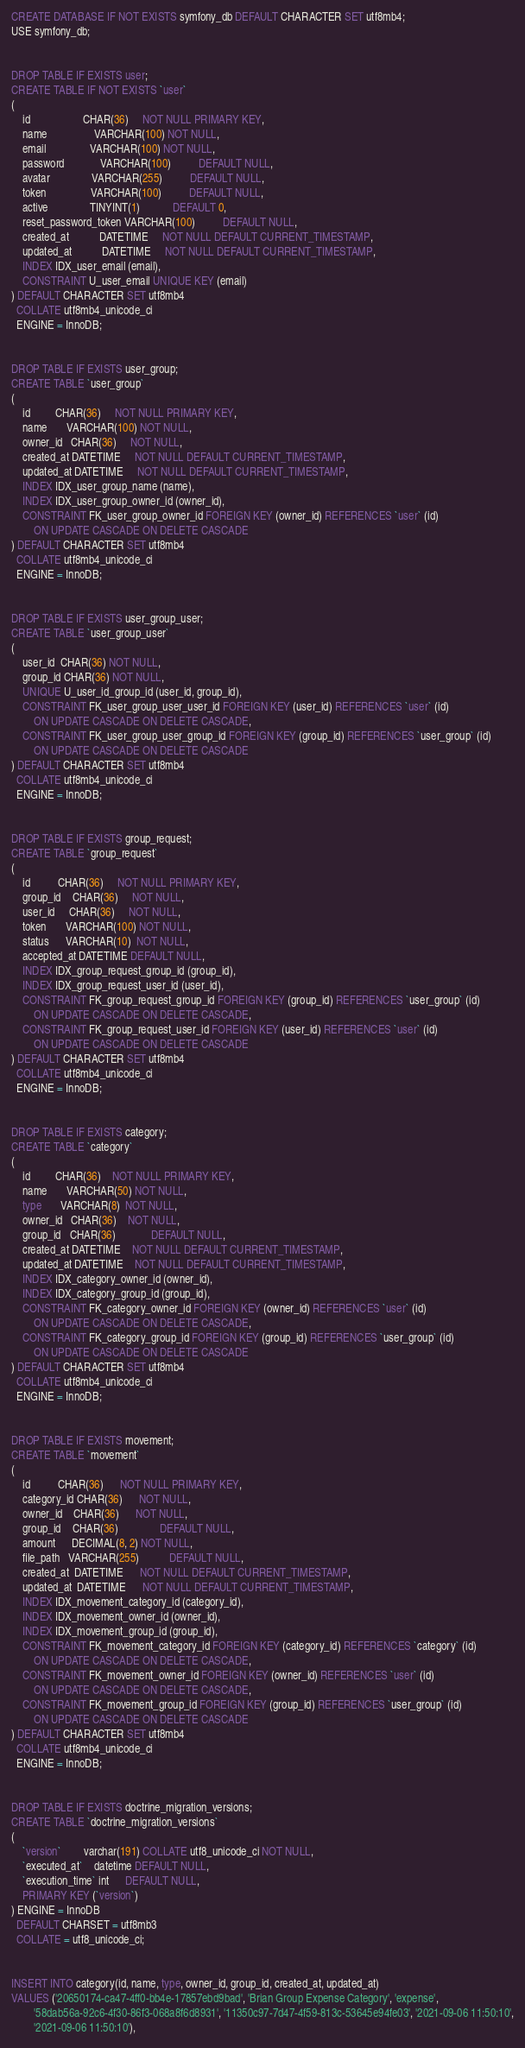Convert code to text. <code><loc_0><loc_0><loc_500><loc_500><_SQL_>CREATE DATABASE IF NOT EXISTS symfony_db DEFAULT CHARACTER SET utf8mb4;
USE symfony_db;


DROP TABLE IF EXISTS user;
CREATE TABLE IF NOT EXISTS `user`
(
    id                   CHAR(36)     NOT NULL PRIMARY KEY,
    name                 VARCHAR(100) NOT NULL,
    email                VARCHAR(100) NOT NULL,
    password             VARCHAR(100)          DEFAULT NULL,
    avatar               VARCHAR(255)          DEFAULT NULL,
    token                VARCHAR(100)          DEFAULT NULL,
    active               TINYINT(1)            DEFAULT 0,
    reset_password_token VARCHAR(100)          DEFAULT NULL,
    created_at           DATETIME     NOT NULL DEFAULT CURRENT_TIMESTAMP,
    updated_at           DATETIME     NOT NULL DEFAULT CURRENT_TIMESTAMP,
    INDEX IDX_user_email (email),
    CONSTRAINT U_user_email UNIQUE KEY (email)
) DEFAULT CHARACTER SET utf8mb4
  COLLATE utf8mb4_unicode_ci
  ENGINE = InnoDB;


DROP TABLE IF EXISTS user_group;
CREATE TABLE `user_group`
(
    id         CHAR(36)     NOT NULL PRIMARY KEY,
    name       VARCHAR(100) NOT NULL,
    owner_id   CHAR(36)     NOT NULL,
    created_at DATETIME     NOT NULL DEFAULT CURRENT_TIMESTAMP,
    updated_at DATETIME     NOT NULL DEFAULT CURRENT_TIMESTAMP,
    INDEX IDX_user_group_name (name),
    INDEX IDX_user_group_owner_id (owner_id),
    CONSTRAINT FK_user_group_owner_id FOREIGN KEY (owner_id) REFERENCES `user` (id)
        ON UPDATE CASCADE ON DELETE CASCADE
) DEFAULT CHARACTER SET utf8mb4
  COLLATE utf8mb4_unicode_ci
  ENGINE = InnoDB;


DROP TABLE IF EXISTS user_group_user;
CREATE TABLE `user_group_user`
(
    user_id  CHAR(36) NOT NULL,
    group_id CHAR(36) NOT NULL,
    UNIQUE U_user_id_group_id (user_id, group_id),
    CONSTRAINT FK_user_group_user_user_id FOREIGN KEY (user_id) REFERENCES `user` (id)
        ON UPDATE CASCADE ON DELETE CASCADE,
    CONSTRAINT FK_user_group_user_group_id FOREIGN KEY (group_id) REFERENCES `user_group` (id)
        ON UPDATE CASCADE ON DELETE CASCADE
) DEFAULT CHARACTER SET utf8mb4
  COLLATE utf8mb4_unicode_ci
  ENGINE = InnoDB;


DROP TABLE IF EXISTS group_request;
CREATE TABLE `group_request`
(
    id          CHAR(36)     NOT NULL PRIMARY KEY,
    group_id    CHAR(36)     NOT NULL,
    user_id     CHAR(36)     NOT NULL,
    token       VARCHAR(100) NOT NULL,
    status      VARCHAR(10)  NOT NULL,
    accepted_at DATETIME DEFAULT NULL,
    INDEX IDX_group_request_group_id (group_id),
    INDEX IDX_group_request_user_id (user_id),
    CONSTRAINT FK_group_request_group_id FOREIGN KEY (group_id) REFERENCES `user_group` (id)
        ON UPDATE CASCADE ON DELETE CASCADE,
    CONSTRAINT FK_group_request_user_id FOREIGN KEY (user_id) REFERENCES `user` (id)
        ON UPDATE CASCADE ON DELETE CASCADE
) DEFAULT CHARACTER SET utf8mb4
  COLLATE utf8mb4_unicode_ci
  ENGINE = InnoDB;


DROP TABLE IF EXISTS category;
CREATE TABLE `category`
(
    id         CHAR(36)    NOT NULL PRIMARY KEY,
    name       VARCHAR(50) NOT NULL,
    type       VARCHAR(8)  NOT NULL,
    owner_id   CHAR(36)    NOT NULL,
    group_id   CHAR(36)             DEFAULT NULL,
    created_at DATETIME    NOT NULL DEFAULT CURRENT_TIMESTAMP,
    updated_at DATETIME    NOT NULL DEFAULT CURRENT_TIMESTAMP,
    INDEX IDX_category_owner_id (owner_id),
    INDEX IDX_category_group_id (group_id),
    CONSTRAINT FK_category_owner_id FOREIGN KEY (owner_id) REFERENCES `user` (id)
        ON UPDATE CASCADE ON DELETE CASCADE,
    CONSTRAINT FK_category_group_id FOREIGN KEY (group_id) REFERENCES `user_group` (id)
        ON UPDATE CASCADE ON DELETE CASCADE
) DEFAULT CHARACTER SET utf8mb4
  COLLATE utf8mb4_unicode_ci
  ENGINE = InnoDB;


DROP TABLE IF EXISTS movement;
CREATE TABLE `movement`
(
    id          CHAR(36)      NOT NULL PRIMARY KEY,
    category_id CHAR(36)      NOT NULL,
    owner_id    CHAR(36)      NOT NULL,
    group_id    CHAR(36)               DEFAULT NULL,
    amount      DECIMAL(8, 2) NOT NULL,
    file_path   VARCHAR(255)           DEFAULT NULL,
    created_at  DATETIME      NOT NULL DEFAULT CURRENT_TIMESTAMP,
    updated_at  DATETIME      NOT NULL DEFAULT CURRENT_TIMESTAMP,
    INDEX IDX_movement_category_id (category_id),
    INDEX IDX_movement_owner_id (owner_id),
    INDEX IDX_movement_group_id (group_id),
    CONSTRAINT FK_movement_category_id FOREIGN KEY (category_id) REFERENCES `category` (id)
        ON UPDATE CASCADE ON DELETE CASCADE,
    CONSTRAINT FK_movement_owner_id FOREIGN KEY (owner_id) REFERENCES `user` (id)
        ON UPDATE CASCADE ON DELETE CASCADE,
    CONSTRAINT FK_movement_group_id FOREIGN KEY (group_id) REFERENCES `user_group` (id)
        ON UPDATE CASCADE ON DELETE CASCADE
) DEFAULT CHARACTER SET utf8mb4
  COLLATE utf8mb4_unicode_ci
  ENGINE = InnoDB;


DROP TABLE IF EXISTS doctrine_migration_versions;
CREATE TABLE `doctrine_migration_versions`
(
    `version`        varchar(191) COLLATE utf8_unicode_ci NOT NULL,
    `executed_at`    datetime DEFAULT NULL,
    `execution_time` int      DEFAULT NULL,
    PRIMARY KEY (`version`)
) ENGINE = InnoDB
  DEFAULT CHARSET = utf8mb3
  COLLATE = utf8_unicode_ci;


INSERT INTO category(id, name, type, owner_id, group_id, created_at, updated_at)
VALUES ('20650174-ca47-4ff0-bb4e-17857ebd9bad', 'Brian Group Expense Category', 'expense',
        '58dab56a-92c6-4f30-86f3-068a8f6d8931', '11350c97-7d47-4f59-813c-53645e94fe03', '2021-09-06 11:50:10',
        '2021-09-06 11:50:10'),</code> 